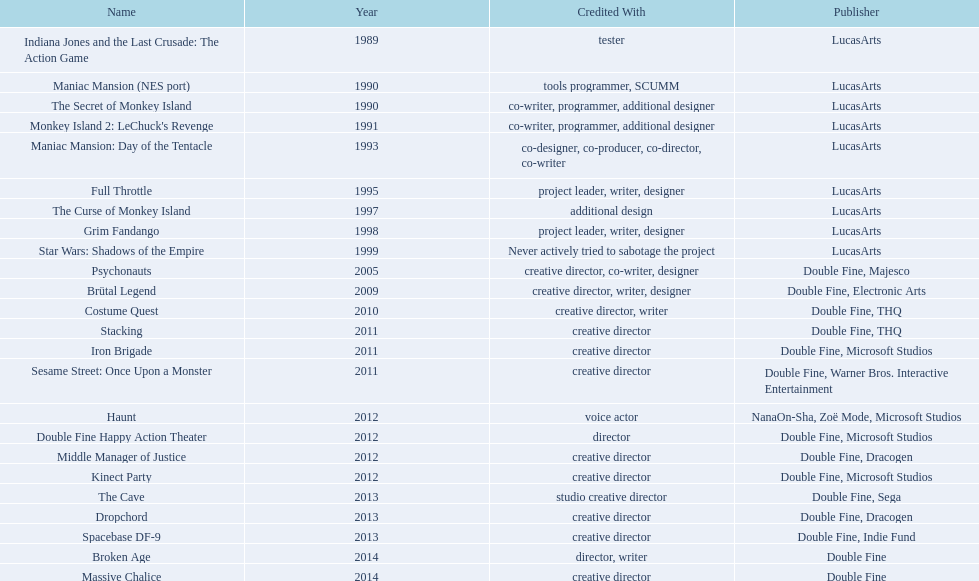What is the name of the game in which tim schafer has taken part? Indiana Jones and the Last Crusade: The Action Game, Maniac Mansion (NES port), The Secret of Monkey Island, Monkey Island 2: LeChuck's Revenge, Maniac Mansion: Day of the Tentacle, Full Throttle, The Curse of Monkey Island, Grim Fandango, Star Wars: Shadows of the Empire, Psychonauts, Brütal Legend, Costume Quest, Stacking, Iron Brigade, Sesame Street: Once Upon a Monster, Haunt, Double Fine Happy Action Theater, Middle Manager of Justice, Kinect Party, The Cave, Dropchord, Spacebase DF-9, Broken Age, Massive Chalice. In which game is he only credited as the creative director? Creative director, creative director, creative director, creative director, creative director, creative director, creative director, creative director. Give me the full table as a dictionary. {'header': ['Name', 'Year', 'Credited With', 'Publisher'], 'rows': [['Indiana Jones and the Last Crusade: The Action Game', '1989', 'tester', 'LucasArts'], ['Maniac Mansion (NES port)', '1990', 'tools programmer, SCUMM', 'LucasArts'], ['The Secret of Monkey Island', '1990', 'co-writer, programmer, additional designer', 'LucasArts'], ["Monkey Island 2: LeChuck's Revenge", '1991', 'co-writer, programmer, additional designer', 'LucasArts'], ['Maniac Mansion: Day of the Tentacle', '1993', 'co-designer, co-producer, co-director, co-writer', 'LucasArts'], ['Full Throttle', '1995', 'project leader, writer, designer', 'LucasArts'], ['The Curse of Monkey Island', '1997', 'additional design', 'LucasArts'], ['Grim Fandango', '1998', 'project leader, writer, designer', 'LucasArts'], ['Star Wars: Shadows of the Empire', '1999', 'Never actively tried to sabotage the project', 'LucasArts'], ['Psychonauts', '2005', 'creative director, co-writer, designer', 'Double Fine, Majesco'], ['Brütal Legend', '2009', 'creative director, writer, designer', 'Double Fine, Electronic Arts'], ['Costume Quest', '2010', 'creative director, writer', 'Double Fine, THQ'], ['Stacking', '2011', 'creative director', 'Double Fine, THQ'], ['Iron Brigade', '2011', 'creative director', 'Double Fine, Microsoft Studios'], ['Sesame Street: Once Upon a Monster', '2011', 'creative director', 'Double Fine, Warner Bros. Interactive Entertainment'], ['Haunt', '2012', 'voice actor', 'NanaOn-Sha, Zoë Mode, Microsoft Studios'], ['Double Fine Happy Action Theater', '2012', 'director', 'Double Fine, Microsoft Studios'], ['Middle Manager of Justice', '2012', 'creative director', 'Double Fine, Dracogen'], ['Kinect Party', '2012', 'creative director', 'Double Fine, Microsoft Studios'], ['The Cave', '2013', 'studio creative director', 'Double Fine, Sega'], ['Dropchord', '2013', 'creative director', 'Double Fine, Dracogen'], ['Spacebase DF-9', '2013', 'creative director', 'Double Fine, Indie Fund'], ['Broken Age', '2014', 'director, writer', 'Double Fine'], ['Massive Chalice', '2014', 'creative director', 'Double Fine']]} Which games meet these criteria and are also published by warner bros. interactive entertainment? Sesame Street: Once Upon a Monster. 